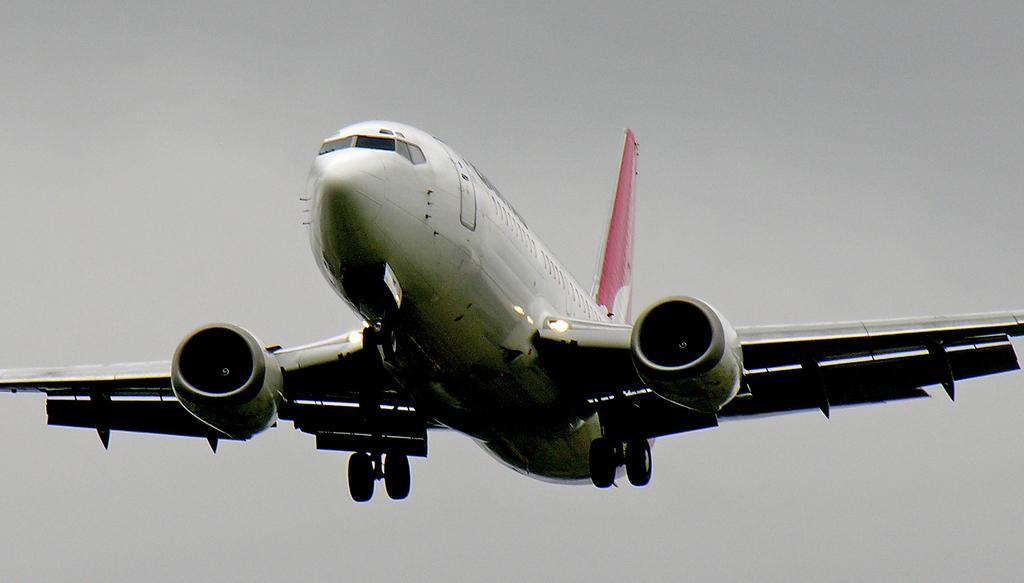In one or two sentences, can you explain what this image depicts? This image consists of a plane in white color. It is in the air. In the background, we can see a sky. 